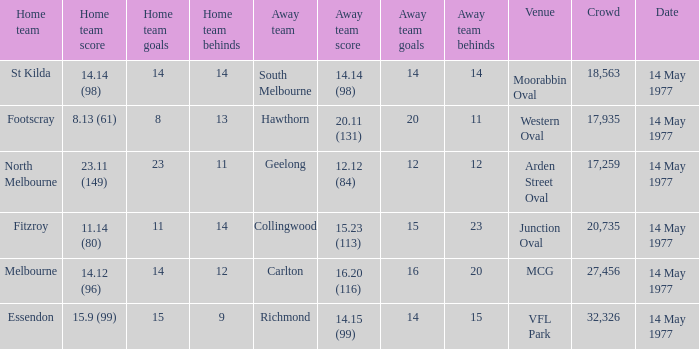Name the away team for essendon Richmond. 